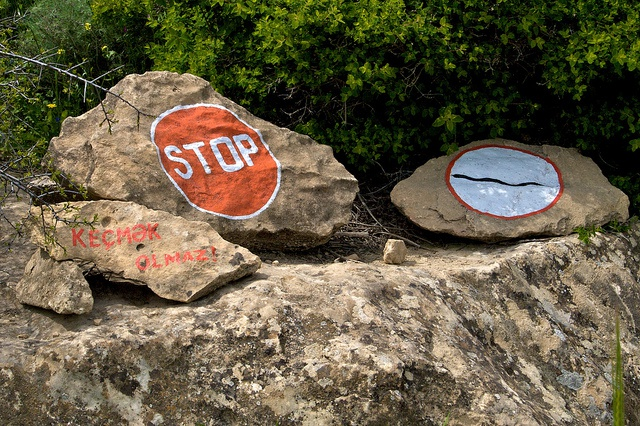Describe the objects in this image and their specific colors. I can see a stop sign in black, brown, salmon, red, and lavender tones in this image. 